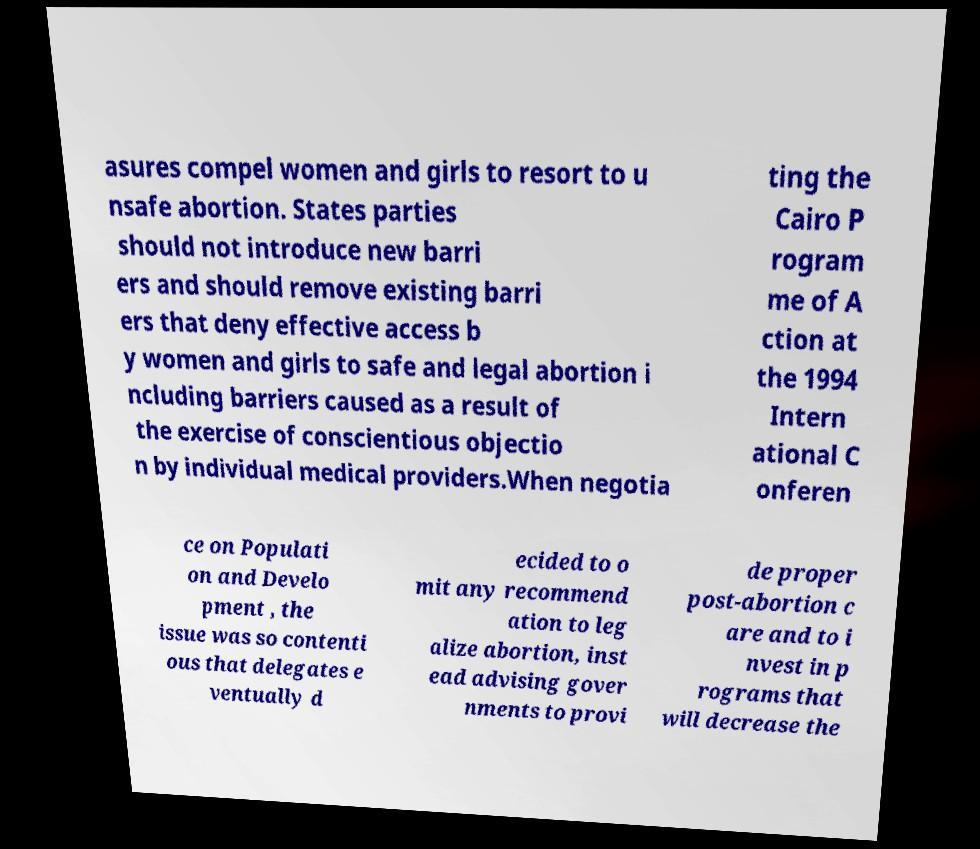There's text embedded in this image that I need extracted. Can you transcribe it verbatim? asures compel women and girls to resort to u nsafe abortion. States parties should not introduce new barri ers and should remove existing barri ers that deny effective access b y women and girls to safe and legal abortion i ncluding barriers caused as a result of the exercise of conscientious objectio n by individual medical providers.When negotia ting the Cairo P rogram me of A ction at the 1994 Intern ational C onferen ce on Populati on and Develo pment , the issue was so contenti ous that delegates e ventually d ecided to o mit any recommend ation to leg alize abortion, inst ead advising gover nments to provi de proper post-abortion c are and to i nvest in p rograms that will decrease the 